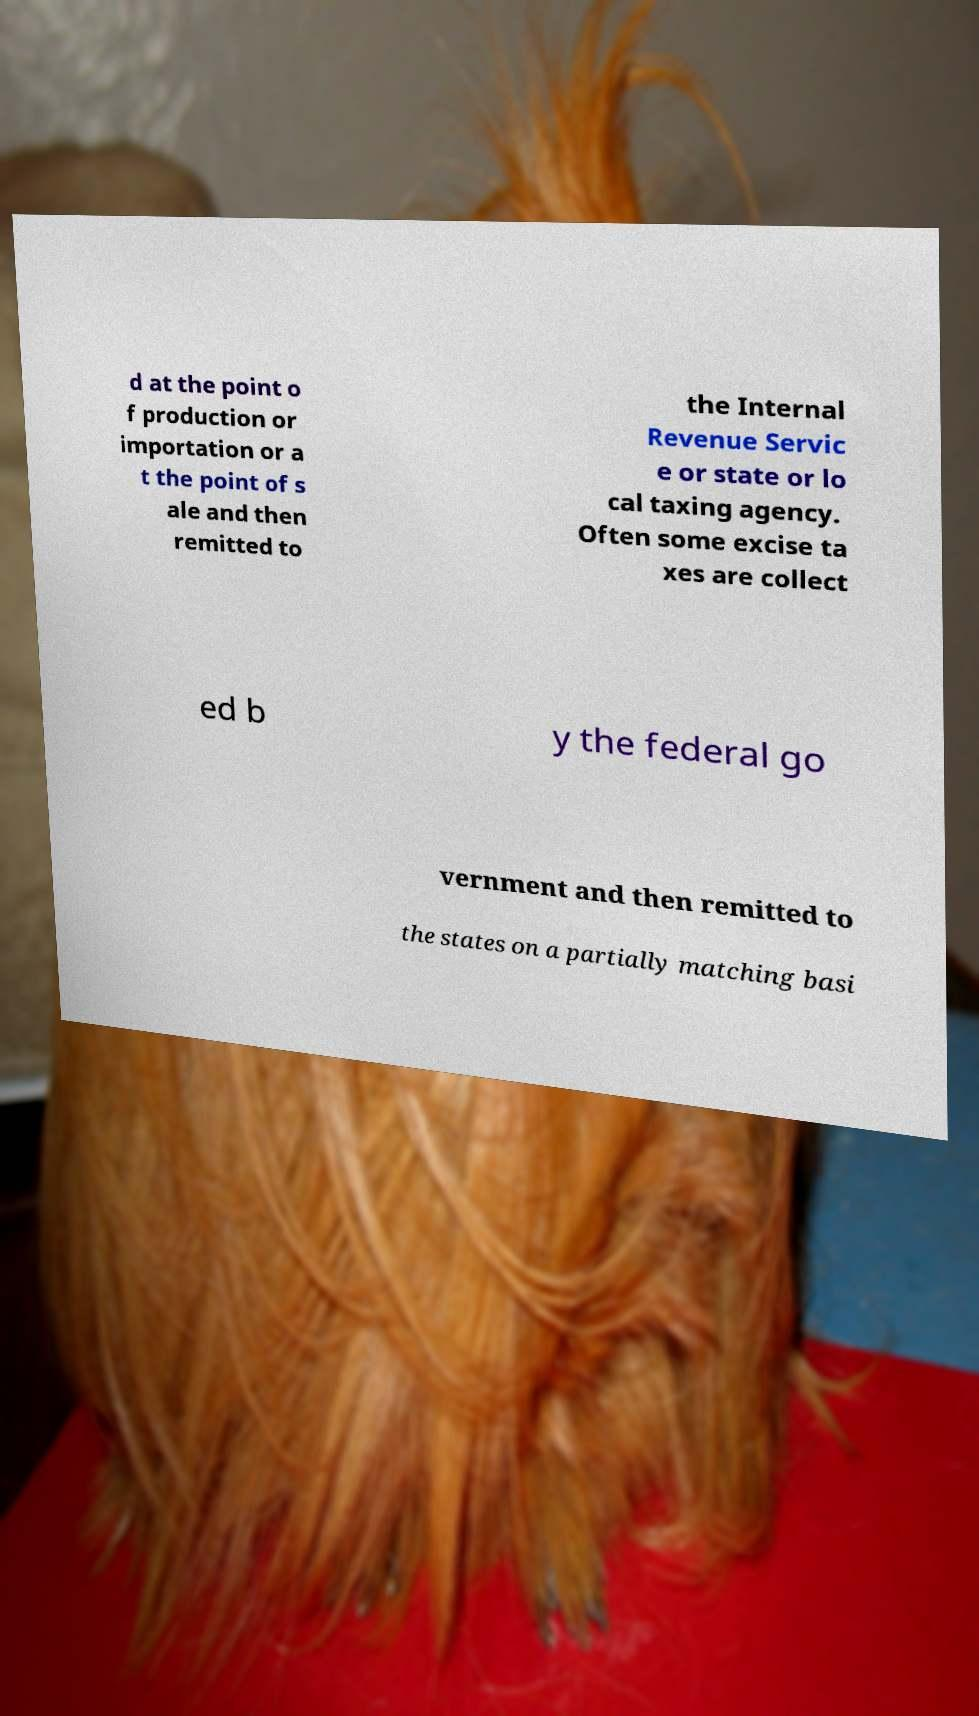I need the written content from this picture converted into text. Can you do that? d at the point o f production or importation or a t the point of s ale and then remitted to the Internal Revenue Servic e or state or lo cal taxing agency. Often some excise ta xes are collect ed b y the federal go vernment and then remitted to the states on a partially matching basi 